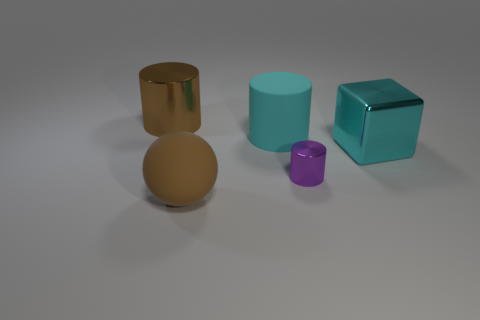Is there anything else that has the same material as the cyan cylinder?
Your answer should be compact. Yes. What material is the cyan object that is the same shape as the purple metal thing?
Give a very brief answer. Rubber. Is the number of cyan shiny cubes that are behind the big cyan block less than the number of large cylinders?
Your answer should be compact. Yes. Do the metallic object that is left of the brown rubber sphere and the tiny shiny thing have the same shape?
Give a very brief answer. Yes. Is there anything else that is the same color as the big shiny cylinder?
Your answer should be very brief. Yes. What is the size of the brown cylinder that is made of the same material as the cube?
Keep it short and to the point. Large. What is the material of the cyan thing that is to the left of the metal cylinder to the right of the rubber thing that is in front of the cyan cube?
Your answer should be compact. Rubber. Are there fewer green matte cubes than brown matte things?
Ensure brevity in your answer.  Yes. Does the brown sphere have the same material as the big cyan cube?
Provide a short and direct response. No. What is the shape of the shiny object that is the same color as the rubber ball?
Make the answer very short. Cylinder. 